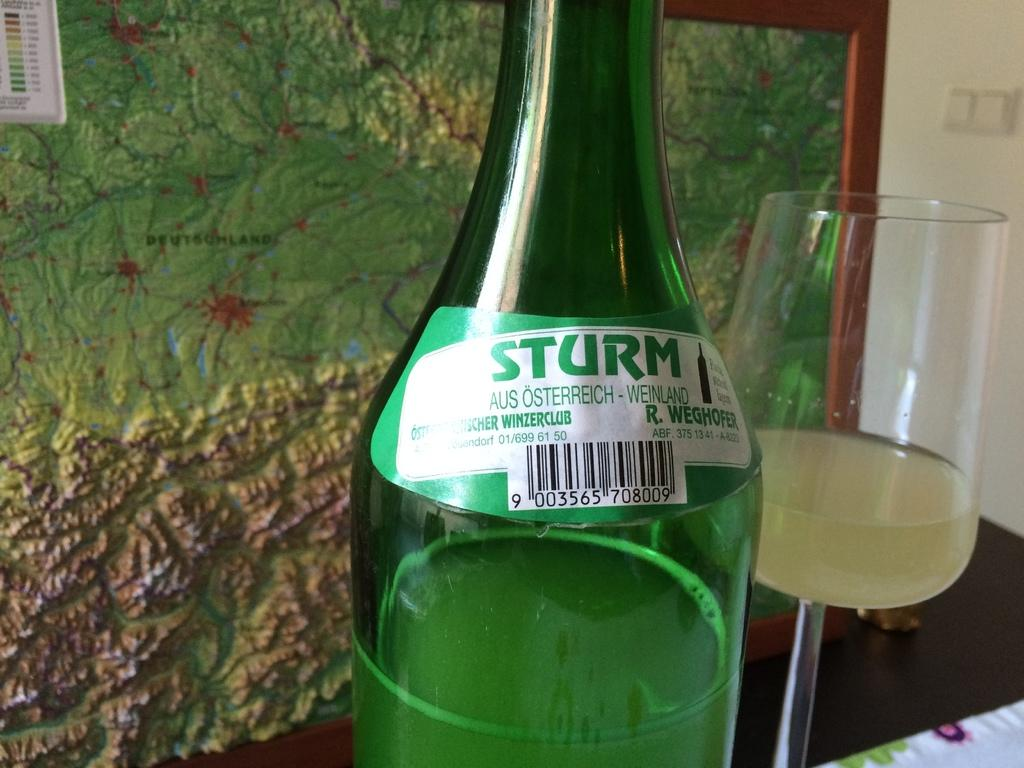<image>
Share a concise interpretation of the image provided. A bottle of Sturm and a glass next to a painting which shows a map of Europe. 